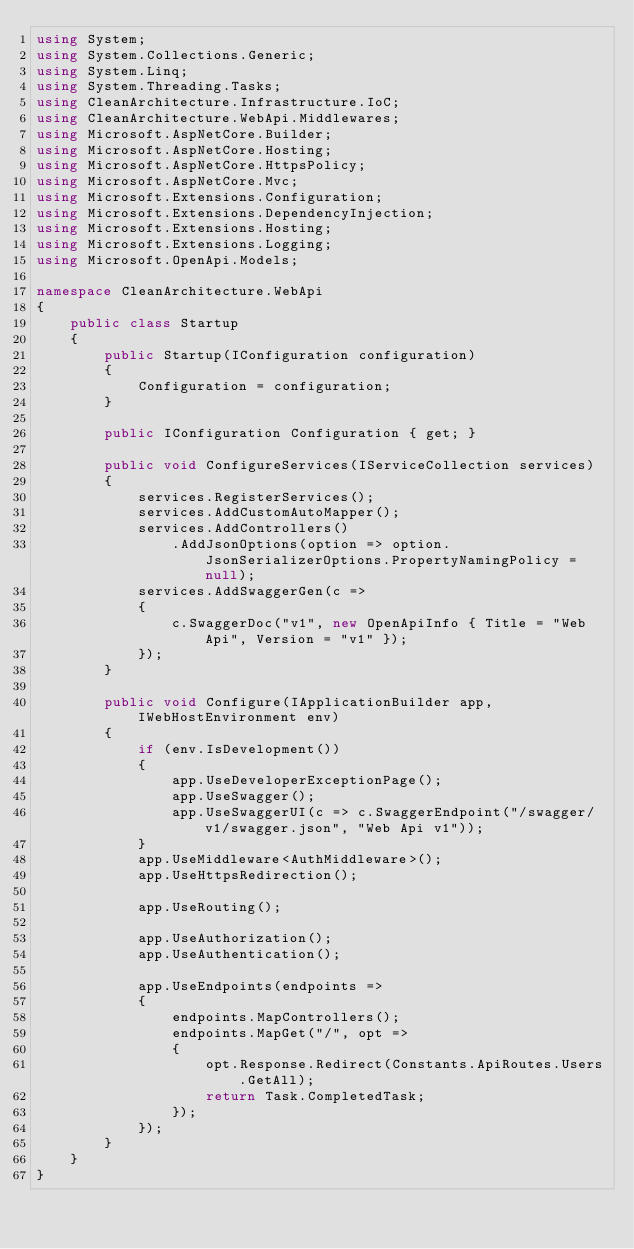<code> <loc_0><loc_0><loc_500><loc_500><_C#_>using System;
using System.Collections.Generic;
using System.Linq;
using System.Threading.Tasks;
using CleanArchitecture.Infrastructure.IoC;
using CleanArchitecture.WebApi.Middlewares;
using Microsoft.AspNetCore.Builder;
using Microsoft.AspNetCore.Hosting;
using Microsoft.AspNetCore.HttpsPolicy;
using Microsoft.AspNetCore.Mvc;
using Microsoft.Extensions.Configuration;
using Microsoft.Extensions.DependencyInjection;
using Microsoft.Extensions.Hosting;
using Microsoft.Extensions.Logging;
using Microsoft.OpenApi.Models;

namespace CleanArchitecture.WebApi
{
    public class Startup
    {
        public Startup(IConfiguration configuration)
        {
            Configuration = configuration;
        }

        public IConfiguration Configuration { get; }

        public void ConfigureServices(IServiceCollection services)
        {
            services.RegisterServices();
            services.AddCustomAutoMapper();
            services.AddControllers()
                .AddJsonOptions(option => option.JsonSerializerOptions.PropertyNamingPolicy = null);
            services.AddSwaggerGen(c =>
            {
                c.SwaggerDoc("v1", new OpenApiInfo { Title = "Web Api", Version = "v1" });
            });
        }

        public void Configure(IApplicationBuilder app, IWebHostEnvironment env)
        {
            if (env.IsDevelopment())
            {
                app.UseDeveloperExceptionPage();
                app.UseSwagger();
                app.UseSwaggerUI(c => c.SwaggerEndpoint("/swagger/v1/swagger.json", "Web Api v1"));
            }
            app.UseMiddleware<AuthMiddleware>();
            app.UseHttpsRedirection();

            app.UseRouting();

            app.UseAuthorization();
            app.UseAuthentication();

            app.UseEndpoints(endpoints =>
            {
                endpoints.MapControllers();
                endpoints.MapGet("/", opt =>
                {
                    opt.Response.Redirect(Constants.ApiRoutes.Users.GetAll);
                    return Task.CompletedTask;
                });
            });
        }
    }
}
</code> 